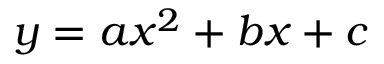<formula> <loc_0><loc_0><loc_500><loc_500>y = a x ^ { 2 } + b x + c</formula> 